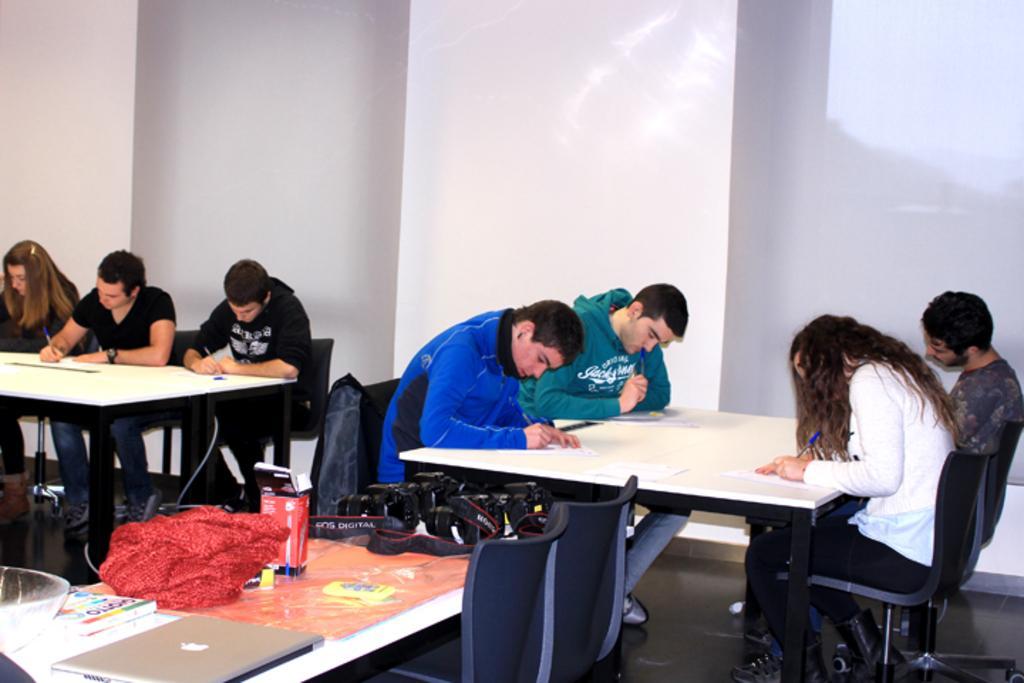In one or two sentences, can you explain what this image depicts? there are so many people sitting on a chair writing something on a paper with the pen. 